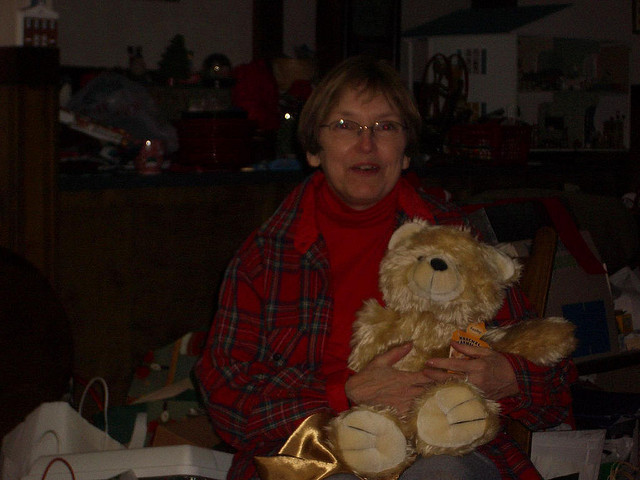<image>Are the bears inside the house? It's unanswerable whether the bears are inside the house or not. Are the bears inside the house? It is unanswerable whether the bears are inside the house or not. 